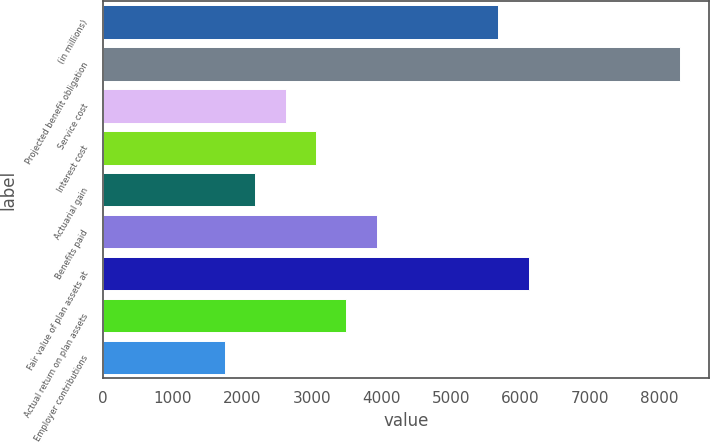Convert chart. <chart><loc_0><loc_0><loc_500><loc_500><bar_chart><fcel>(in millions)<fcel>Projected benefit obligation<fcel>Service cost<fcel>Interest cost<fcel>Actuarial gain<fcel>Benefits paid<fcel>Fair value of plan assets at<fcel>Actual return on plan assets<fcel>Employer contributions<nl><fcel>5685.07<fcel>8307.13<fcel>2626<fcel>3063.01<fcel>2188.99<fcel>3937.03<fcel>6122.08<fcel>3500.02<fcel>1751.98<nl></chart> 